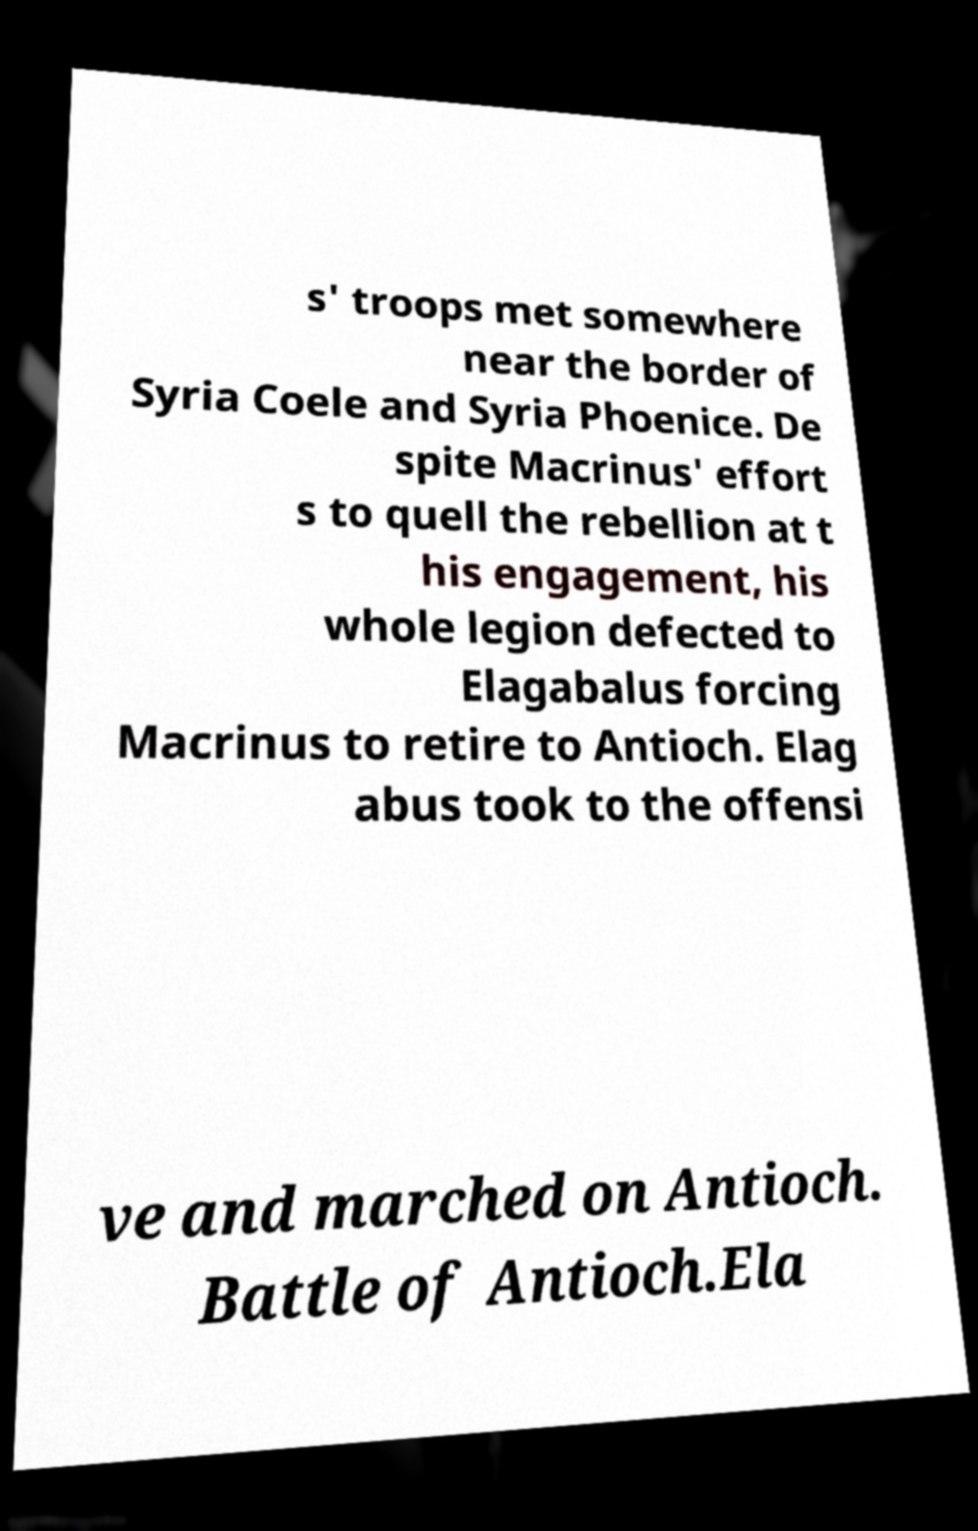Please identify and transcribe the text found in this image. s' troops met somewhere near the border of Syria Coele and Syria Phoenice. De spite Macrinus' effort s to quell the rebellion at t his engagement, his whole legion defected to Elagabalus forcing Macrinus to retire to Antioch. Elag abus took to the offensi ve and marched on Antioch. Battle of Antioch.Ela 